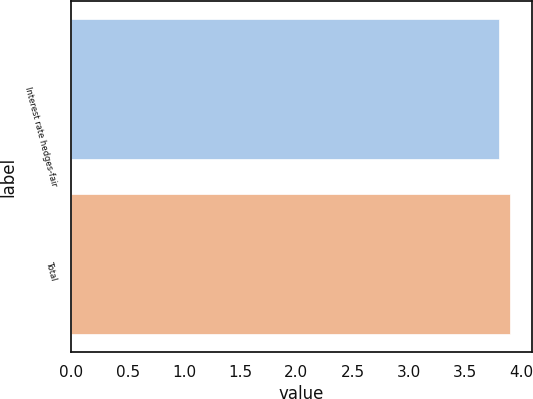Convert chart. <chart><loc_0><loc_0><loc_500><loc_500><bar_chart><fcel>Interest rate hedges-fair<fcel>Total<nl><fcel>3.8<fcel>3.9<nl></chart> 